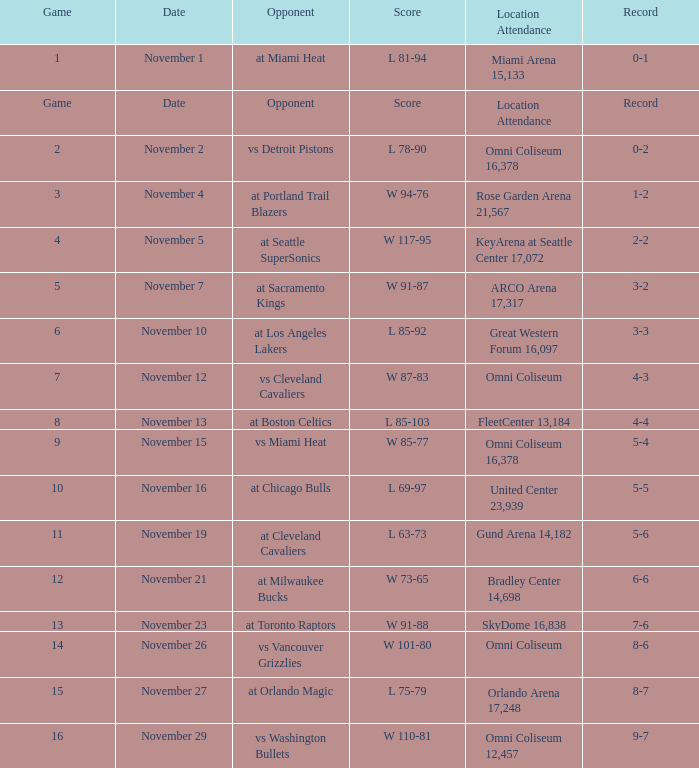Who was their rival in game 4? At seattle supersonics. 